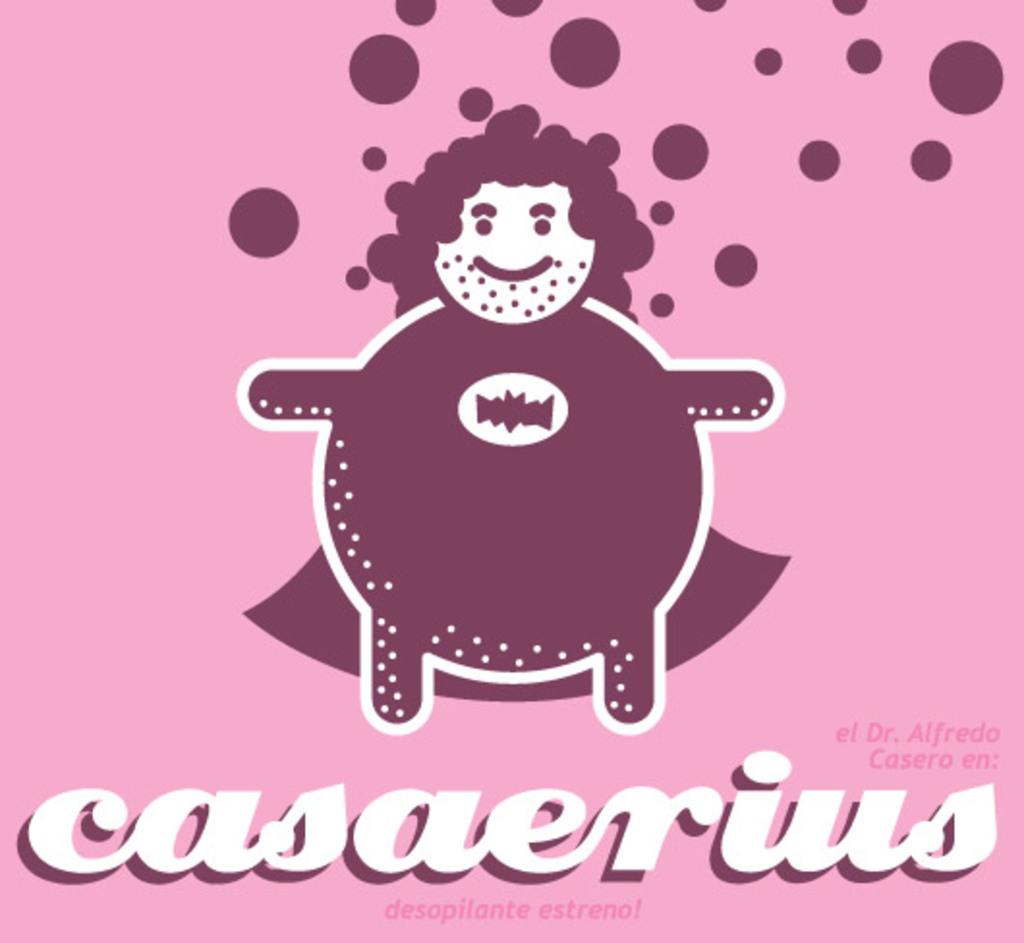What is kind of soda is that?
Offer a terse response. Casaerius. 